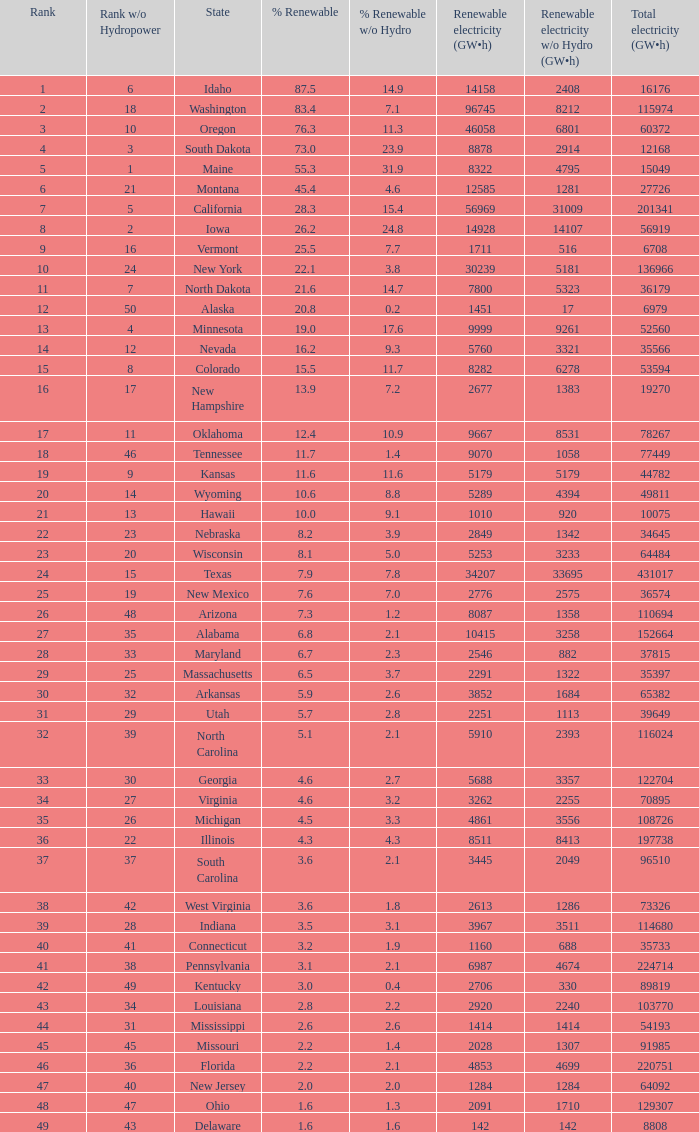What is the maximum renewable energy (gw×h) for the state of Delaware? 142.0. 